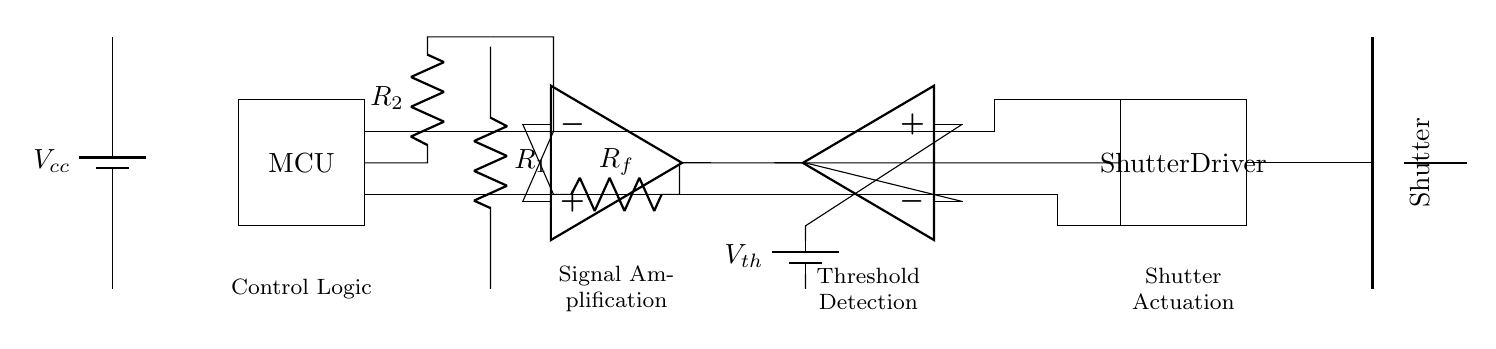What is the main function of the light sensor? The light sensor detects light changes, triggering the circuit to capture images of moving athletes.
Answer: detects light What is the purpose of the microcontroller? The microcontroller processes signals from the light sensor and controls the shutter driver to capture images at the right moment.
Answer: control logic What voltage represents the threshold voltage in this circuit? The threshold voltage is indicated as Vth in the diagram, which sets the light level that must be exceeded for the shutter to trigger.
Answer: Vth What component amplifies the signal from the light sensor? The operational amplifier, labeled op amp in the circuit, amplifies the signal from the light sensor to ensure it is strong enough for processing.
Answer: operational amplifier How does the shutter driver connect to the shutter mechanism? The shutter driver connects directly to the shutter mechanism with a straightforward wire link, enabling it to activate the shutter when required.
Answer: direct wire connection What role does the resistor R1 play in the circuit? Resistor R1 is part of the light sensor configuration, helping to set the sensitivity levels and potentially filtering out noise in the signal detected.
Answer: adjusts sensitivity What triggers the shutter actuation in this circuit? The shutter actuation is triggered when the output of the comparator exceeds a certain level, indicating that the light signal (from the sensor) has passed the threshold.
Answer: output from comparator 